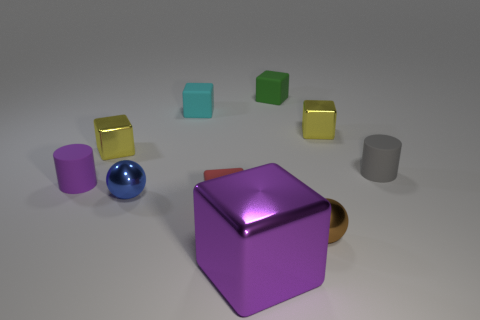Subtract all purple blocks. How many blocks are left? 5 Subtract all big blocks. How many blocks are left? 5 Subtract all purple cubes. Subtract all blue balls. How many cubes are left? 5 Subtract all spheres. How many objects are left? 8 Add 8 purple shiny things. How many purple shiny things exist? 9 Subtract 1 purple blocks. How many objects are left? 9 Subtract all blue objects. Subtract all small yellow rubber objects. How many objects are left? 9 Add 1 tiny red blocks. How many tiny red blocks are left? 2 